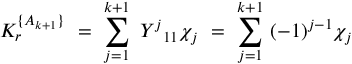<formula> <loc_0><loc_0><loc_500><loc_500>K _ { r } ^ { \{ A _ { k + 1 } \} } \ = \ \sum _ { j = 1 } ^ { k + 1 } \ { { Y } ^ { j } } _ { 1 1 } \chi _ { j } \ = \ \sum _ { j = 1 } ^ { k + 1 } \ ( - 1 ) ^ { j - 1 } \chi _ { j }</formula> 